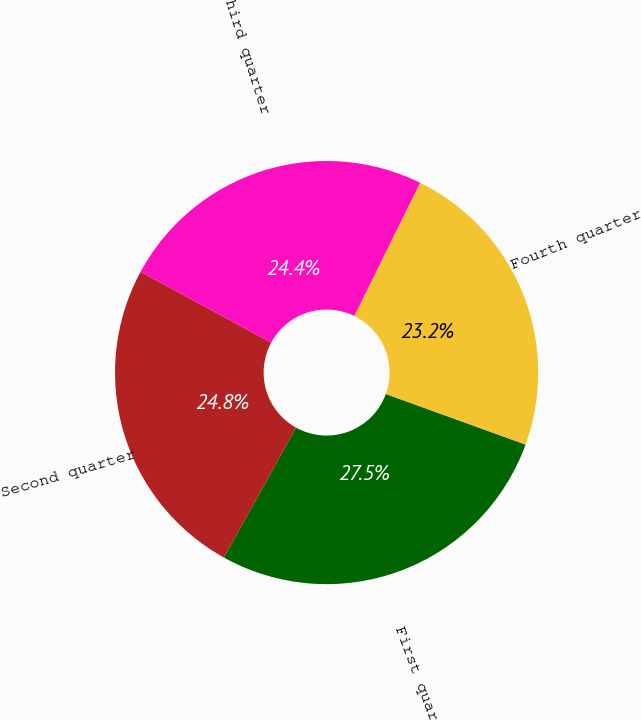Convert chart. <chart><loc_0><loc_0><loc_500><loc_500><pie_chart><fcel>First quarter<fcel>Second quarter<fcel>Third quarter<fcel>Fourth quarter<nl><fcel>27.54%<fcel>24.83%<fcel>24.4%<fcel>23.23%<nl></chart> 